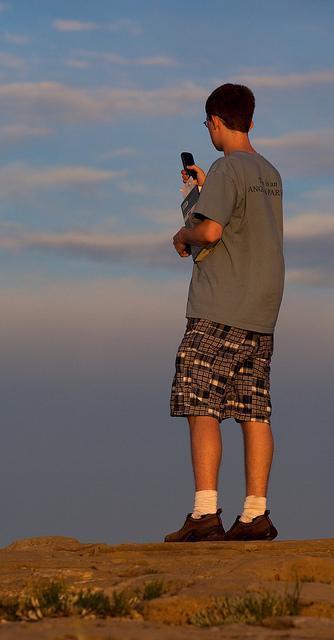How many people in the boat are wearing life jackets?
Give a very brief answer. 0. 